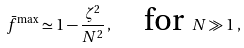Convert formula to latex. <formula><loc_0><loc_0><loc_500><loc_500>\bar { f } ^ { \max } \simeq 1 - \frac { \zeta ^ { 2 } } { N ^ { 2 } } \, , \quad \text {for} \ N \gg 1 \, ,</formula> 